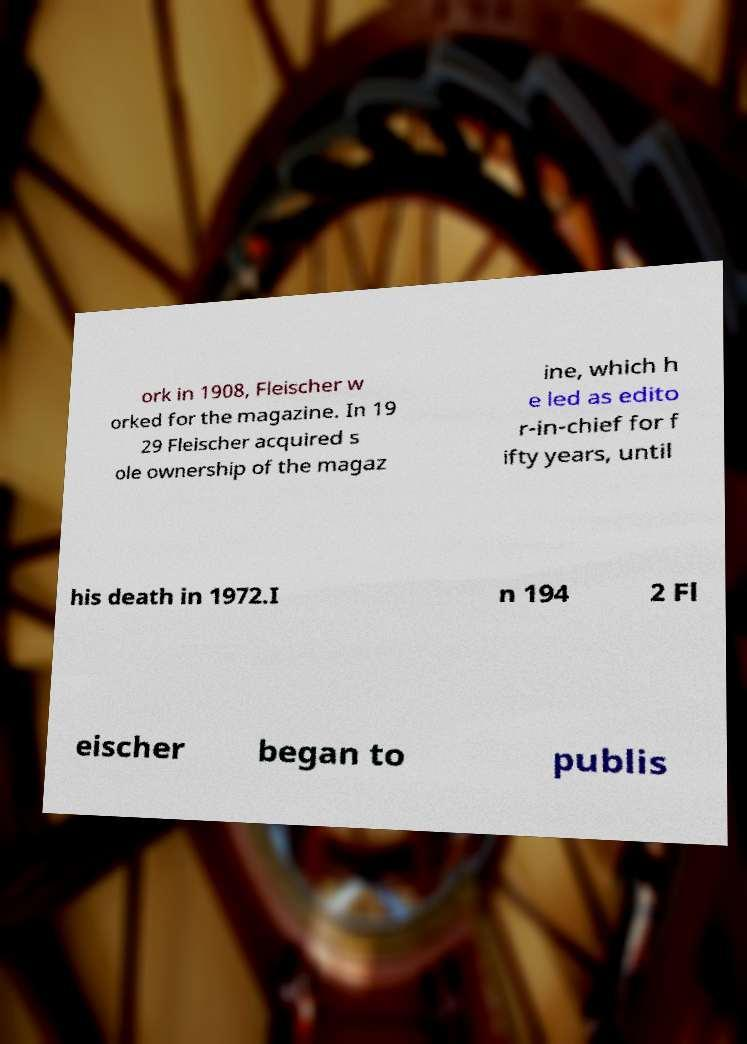I need the written content from this picture converted into text. Can you do that? ork in 1908, Fleischer w orked for the magazine. In 19 29 Fleischer acquired s ole ownership of the magaz ine, which h e led as edito r-in-chief for f ifty years, until his death in 1972.I n 194 2 Fl eischer began to publis 